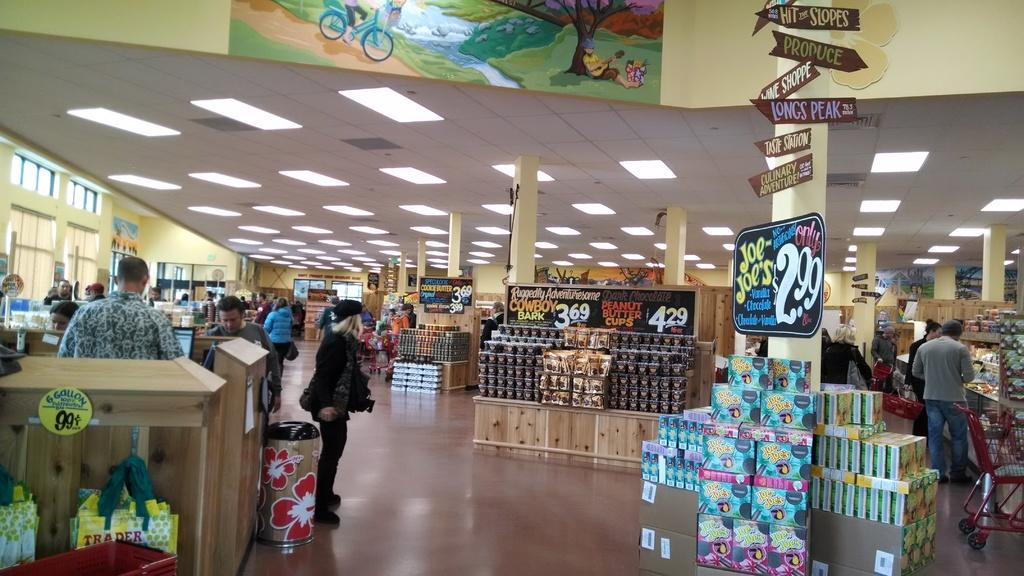<image>
Render a clear and concise summary of the photo. A grocery store has various sweets to offer, including peanut butter cups for $4.29. 